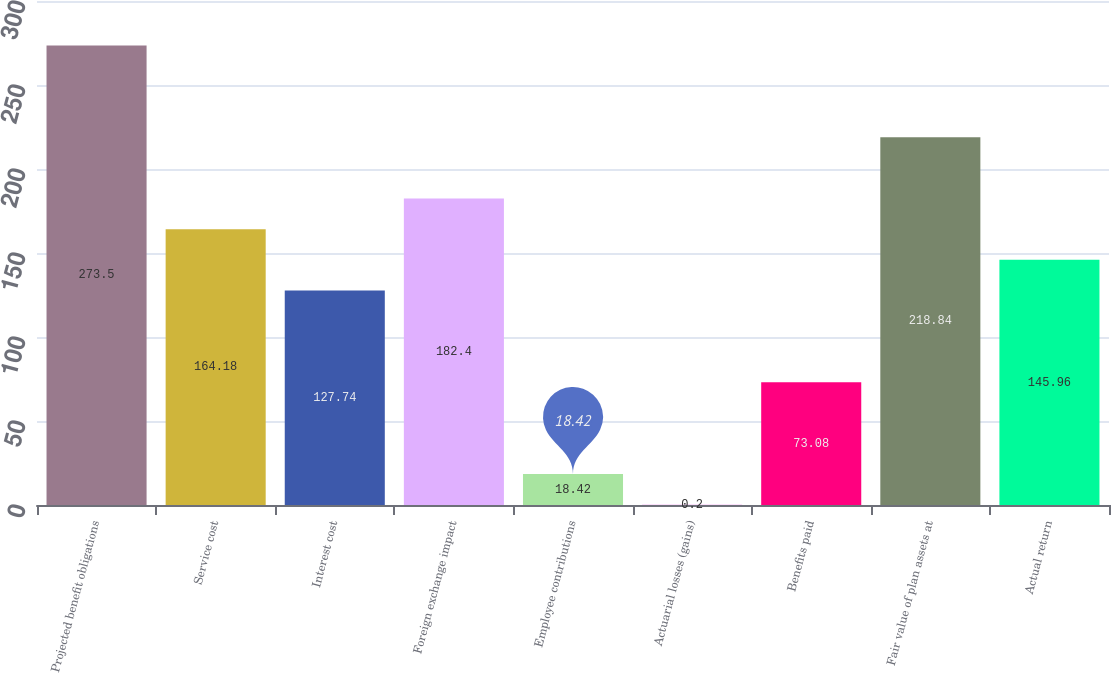Convert chart to OTSL. <chart><loc_0><loc_0><loc_500><loc_500><bar_chart><fcel>Projected benefit obligations<fcel>Service cost<fcel>Interest cost<fcel>Foreign exchange impact<fcel>Employee contributions<fcel>Actuarial losses (gains)<fcel>Benefits paid<fcel>Fair value of plan assets at<fcel>Actual return<nl><fcel>273.5<fcel>164.18<fcel>127.74<fcel>182.4<fcel>18.42<fcel>0.2<fcel>73.08<fcel>218.84<fcel>145.96<nl></chart> 